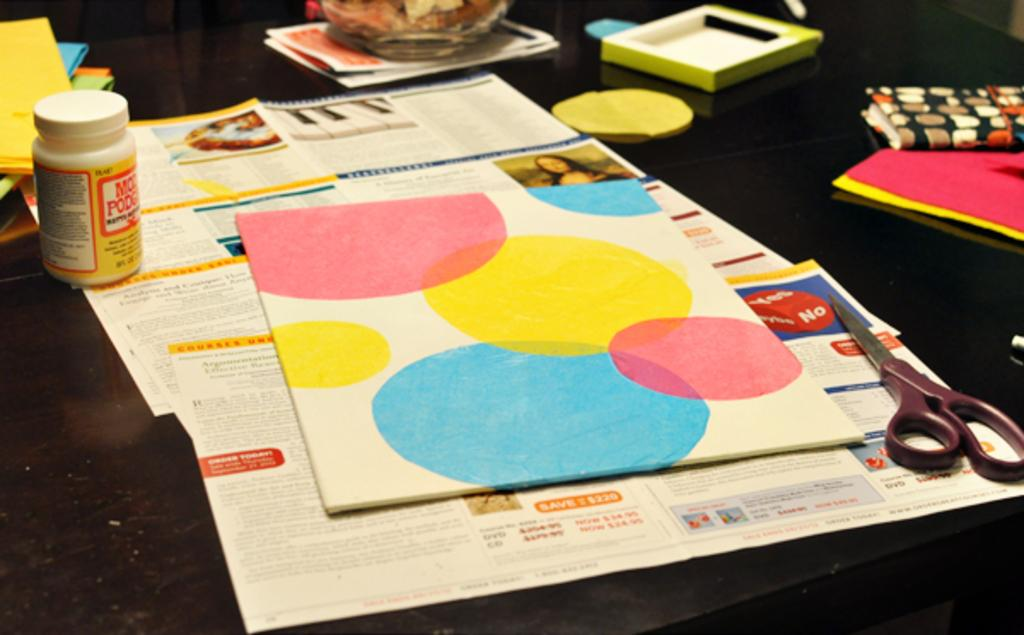What type of objects are present in the image? There are papers, scissors, small bottles, and books in the image. Can you describe the tools that might be used for cutting in the image? There are scissors in the image that can be used for cutting. What type of items are contained in the small bottles in the image? The contents of the small bottles are not visible in the image, so it cannot be determined what they contain. What might be used for reading or studying in the image? There are books in the image that can be used for reading or studying. Can you tell me how many ants are crawling on the papers in the image? There are no ants present on the papers in the image. What type of animal is visible in the image, and where is it located? There is no animal visible in the image; it features papers, scissors, small bottles, and books. 